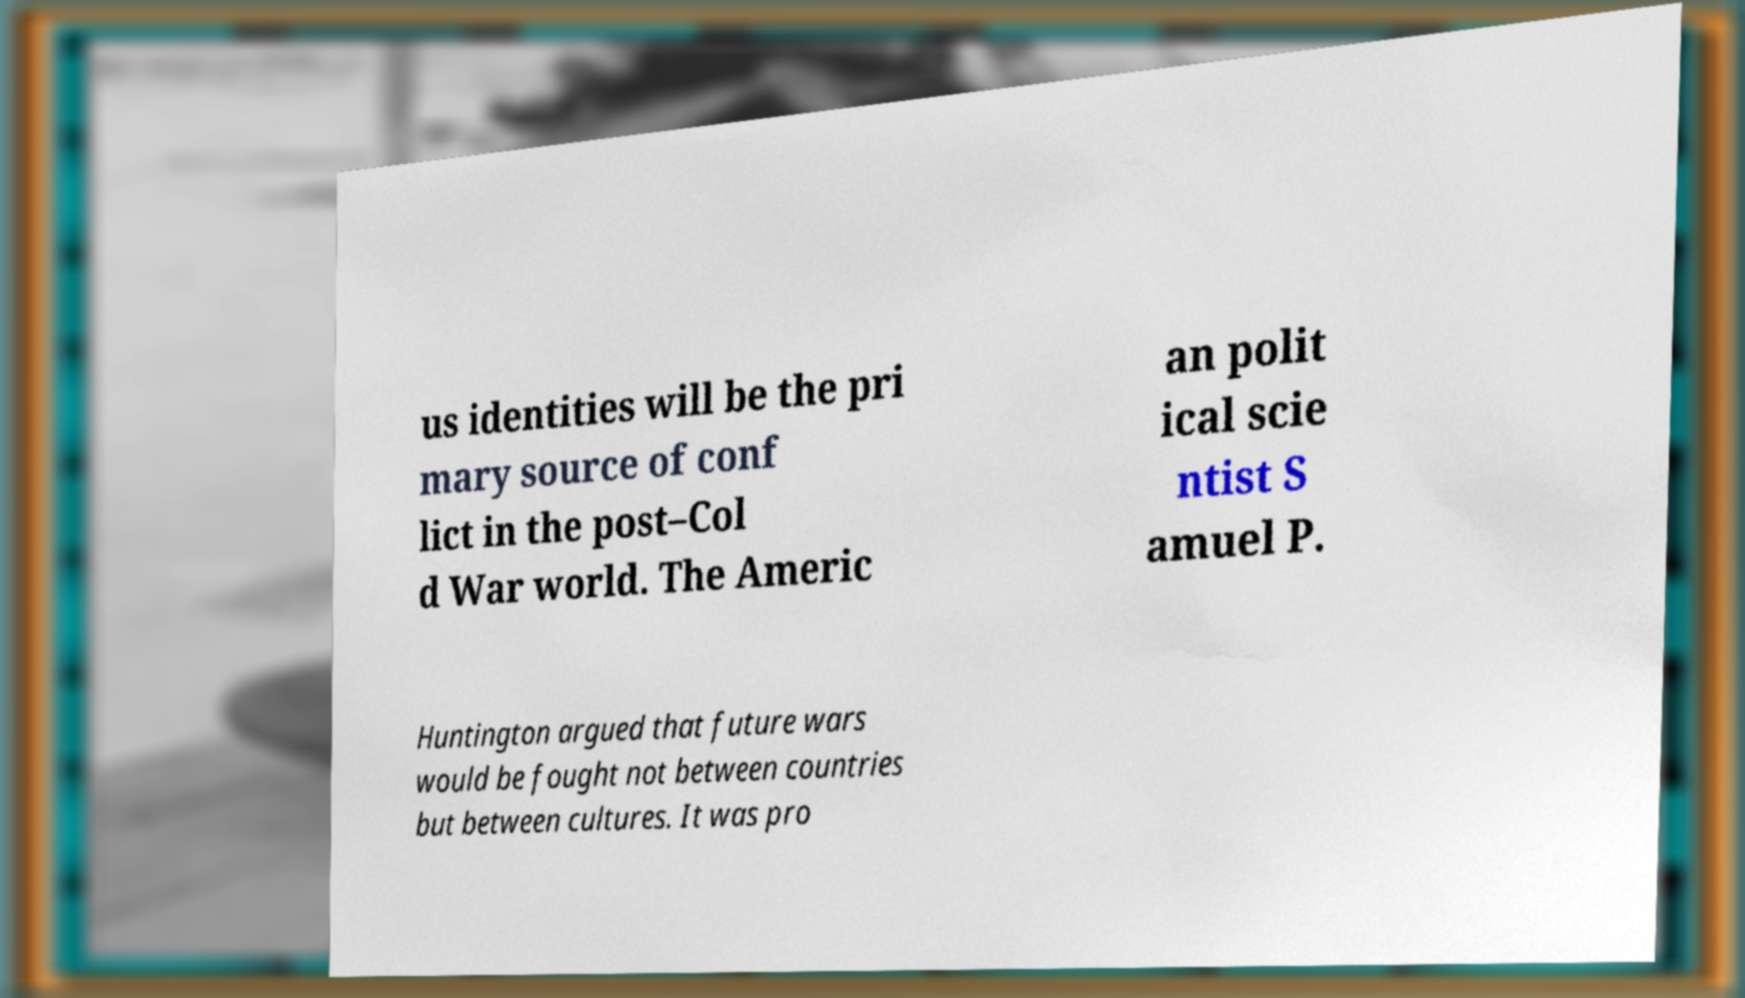For documentation purposes, I need the text within this image transcribed. Could you provide that? us identities will be the pri mary source of conf lict in the post–Col d War world. The Americ an polit ical scie ntist S amuel P. Huntington argued that future wars would be fought not between countries but between cultures. It was pro 